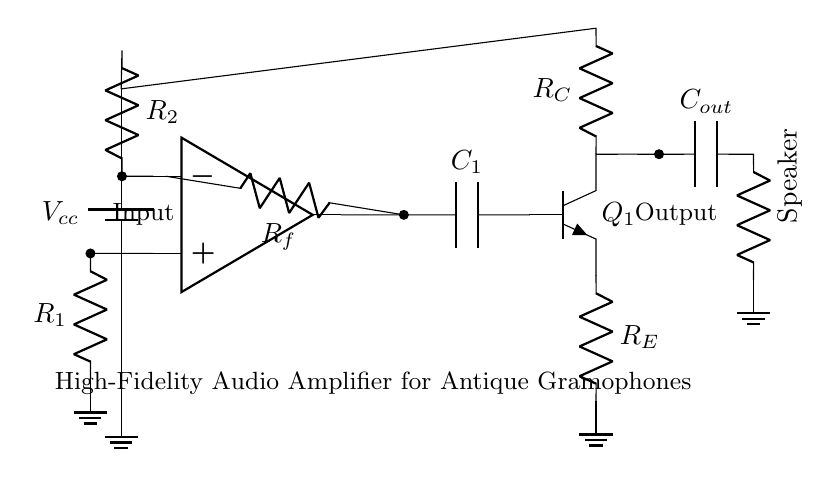What is the primary function of the circuit? The primary function of the circuit is to amplify audio signals from antique gramophones, providing a high-fidelity output suitable for playback.
Answer: Amplification What type of amplifier component is used in this circuit? The circuit contains an operational amplifier, which is crucial for signal amplification and conditioning.
Answer: Operational amplifier How many resistors are present in the circuit? The circuit consists of three resistors: R1, R2, and Rf, which are essential for setting gain and feedback in the amplifier.
Answer: Three What is the purpose of C1 in the circuit? Capacitor C1 is used for coupling, allowing AC audio signals to pass while blocking DC components, ensuring that only the intended audio frequencies are amplified.
Answer: Coupling What is the output load of this amplifier? The output load in this circuit is indicated as a speaker, which converts the amplified electrical signal back into sound.
Answer: Speaker What is the significance of R_E in the output stage? Resistor R_E is an emitter resistor that helps stabilize the biasing of the transistor Q1, ensuring linear operation and enhancing overall circuit stability.
Answer: Stability What is the voltage source labeled as? The voltage source in the circuit is labeled as V_cc, which powers the operational amplifier and the output stage.
Answer: V_cc 